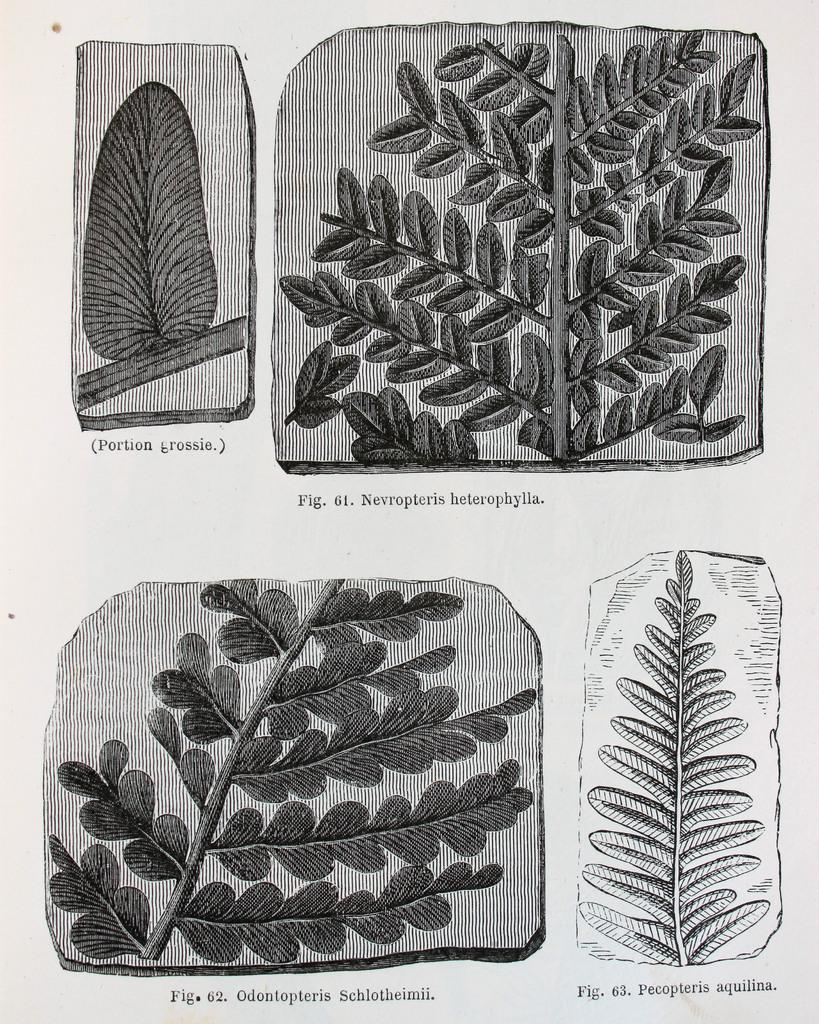What type of artwork is shown in the image? The image is a painting. What is the main subject of the painting? The painting depicts leaves. What is the value of the faucet in the painting? There is no faucet present in the painting; it only depicts leaves. 